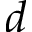<formula> <loc_0><loc_0><loc_500><loc_500>d</formula> 